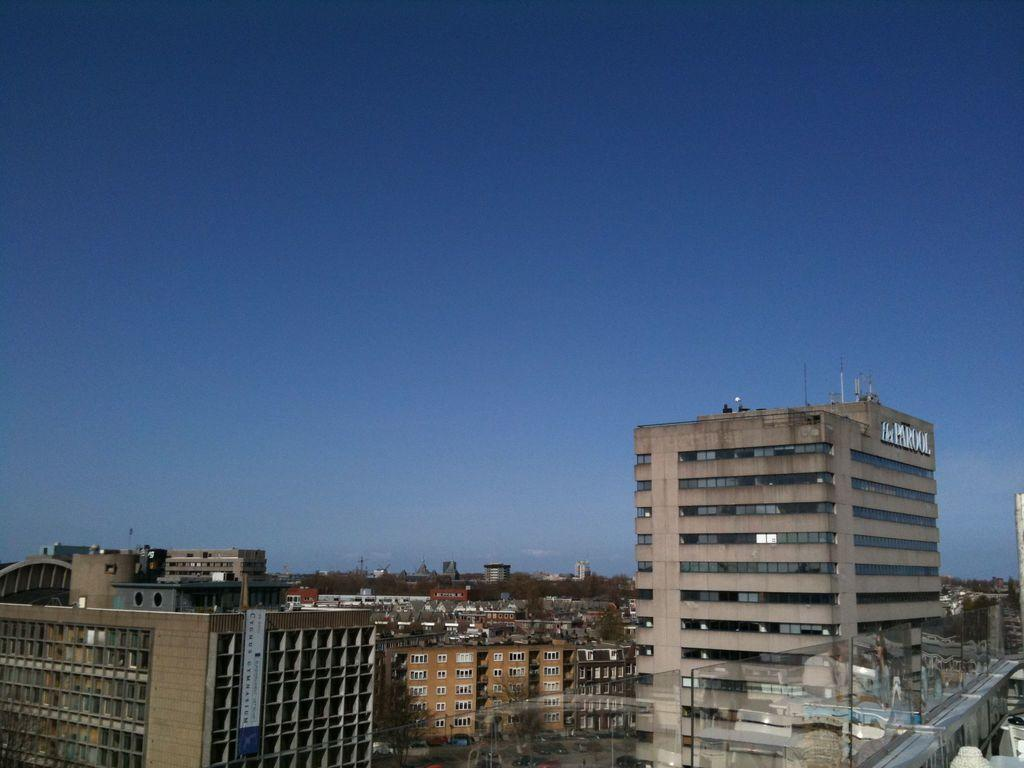What type of structures can be seen in the image? There are many buildings in the image. What type of vegetation is present at the bottom of the image? There are trees at the bottom of the image. What part of the natural environment is visible in the image? The sky is visible in the image. Can you tell me how many fire hydrants are visible in the image? There is no fire hydrant present in the image. What type of medical professional can be seen treating patients in the image? There is no doctor present in the image. 